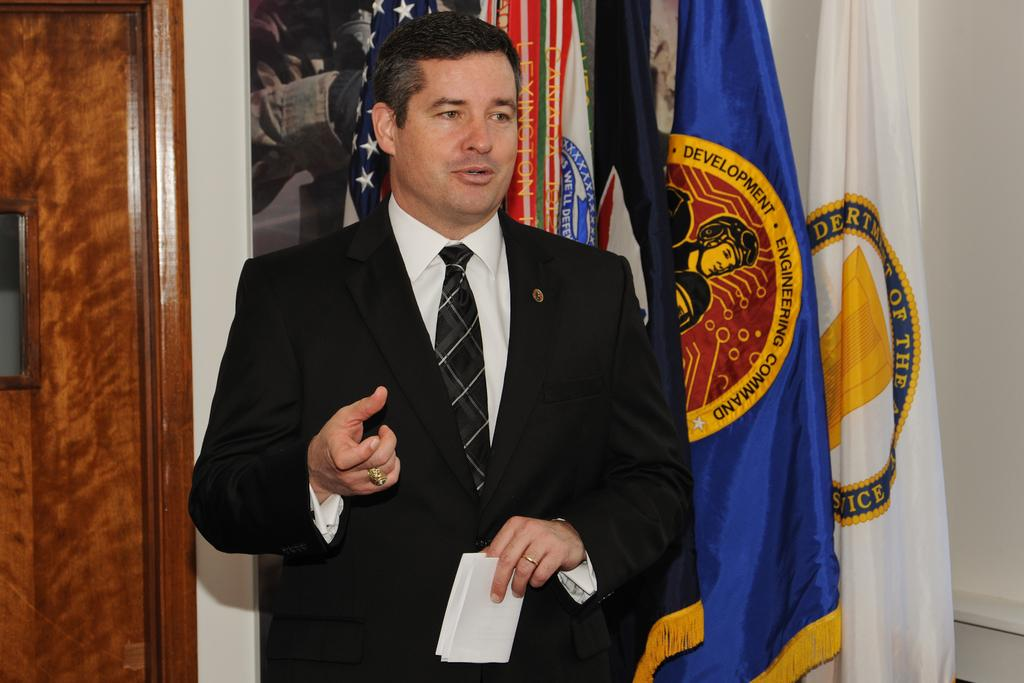<image>
Give a short and clear explanation of the subsequent image. A man stands in front of several flags, one reading Development Engineering Command. 